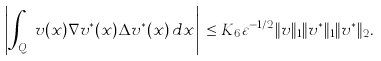<formula> <loc_0><loc_0><loc_500><loc_500>\left | \int _ { Q _ { \varepsilon } } v ( x ) \nabla v ^ { * } ( x ) \Delta v ^ { * } ( x ) \, d x \right | \, \leq K _ { 6 } \varepsilon ^ { - 1 / 2 } \| v \| _ { 1 } \| v ^ { * } \| _ { 1 } \| v ^ { * } \| _ { 2 } .</formula> 